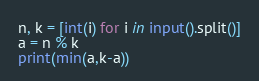<code> <loc_0><loc_0><loc_500><loc_500><_Python_>n, k = [int(i) for i in input().split()]
a = n % k
print(min(a,k-a))</code> 